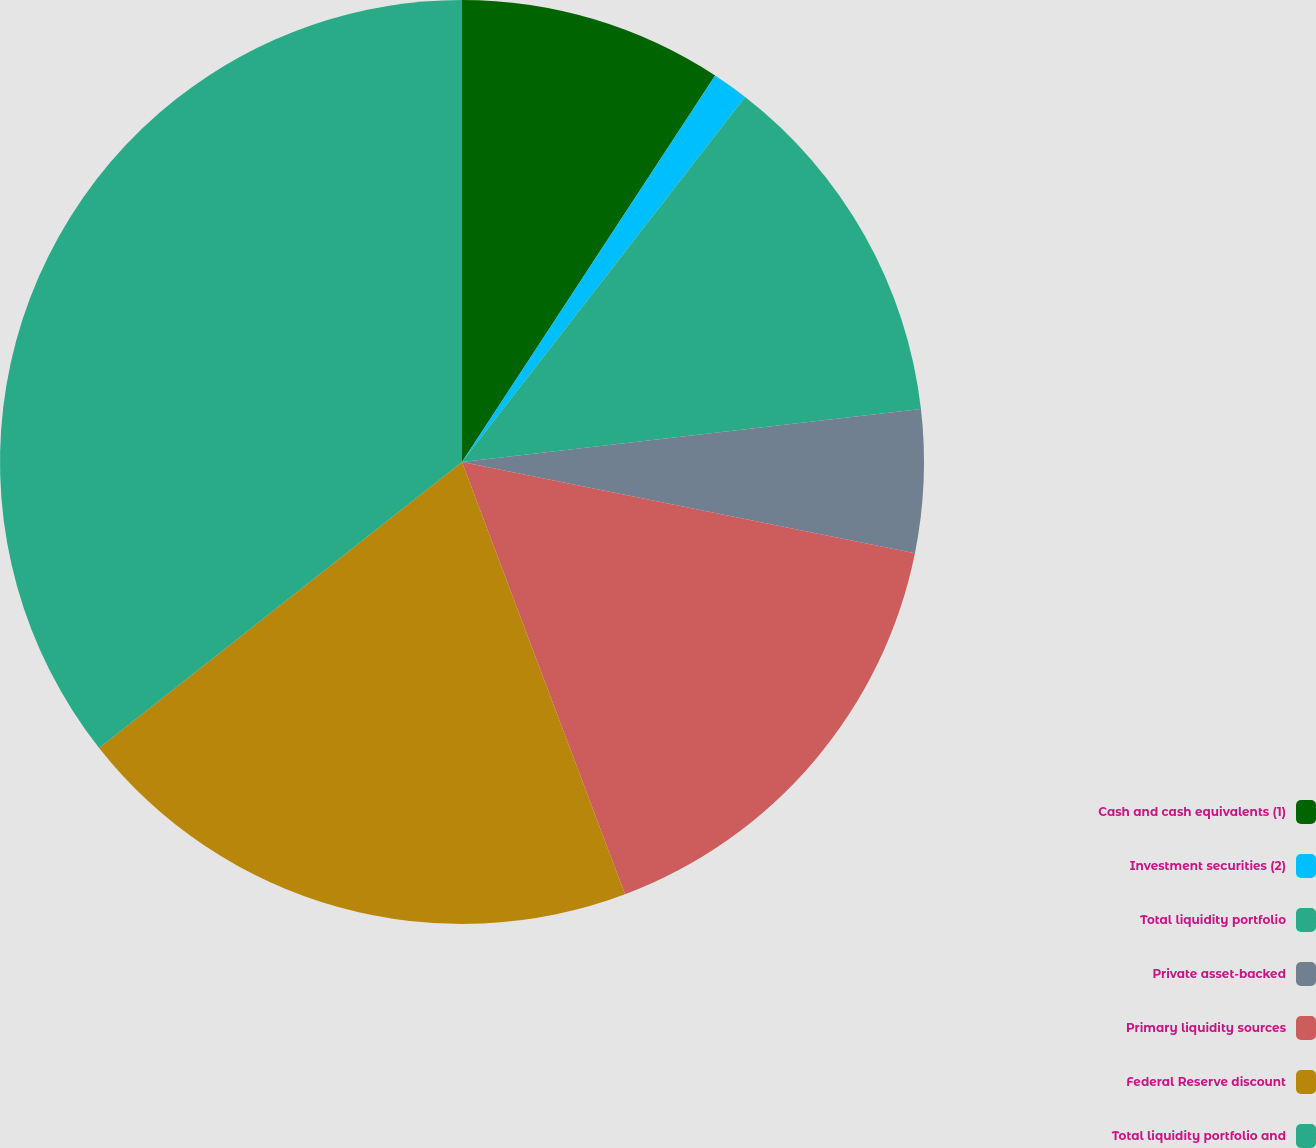Convert chart. <chart><loc_0><loc_0><loc_500><loc_500><pie_chart><fcel>Cash and cash equivalents (1)<fcel>Investment securities (2)<fcel>Total liquidity portfolio<fcel>Private asset-backed<fcel>Primary liquidity sources<fcel>Federal Reserve discount<fcel>Total liquidity portfolio and<nl><fcel>9.23%<fcel>1.27%<fcel>12.67%<fcel>4.99%<fcel>16.1%<fcel>20.12%<fcel>35.62%<nl></chart> 